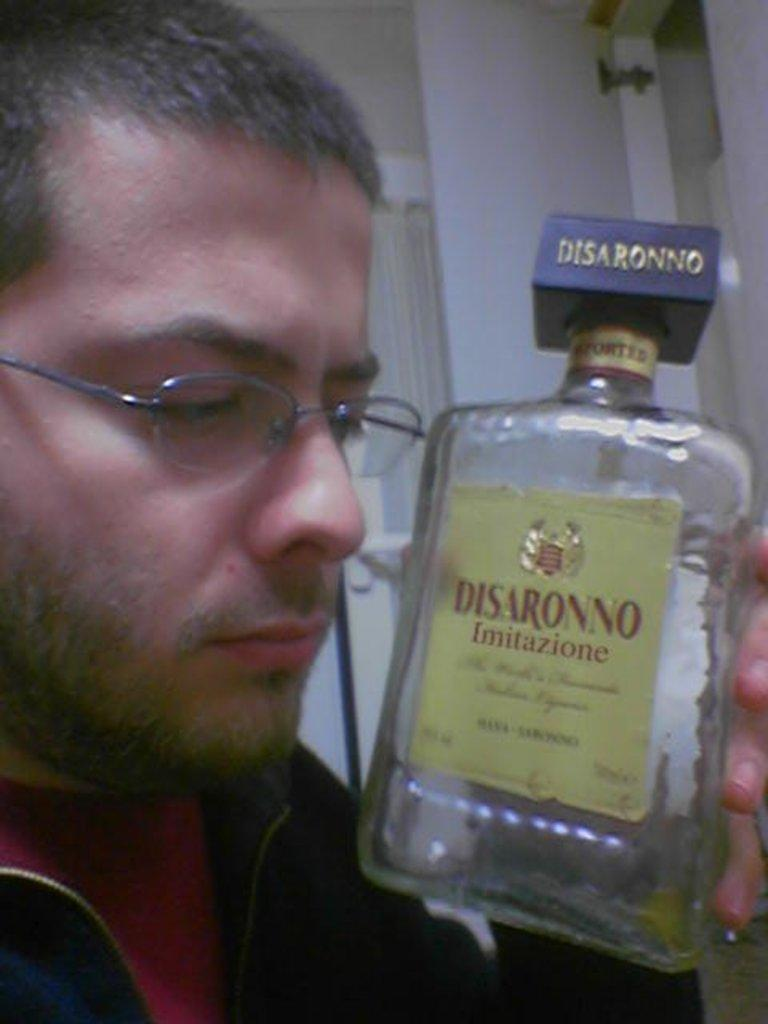What is the person holding in the image? The person is holding a bottle. Can you describe the person's appearance in the image? The person is wearing a spectacle. What can be seen in the background of the image? There is a window visible in the background. How many boats can be seen in the image? There are no boats present in the image. What is the person's sister doing in the image? There is no mention of a sister in the image, and therefore no such activity can be observed. 